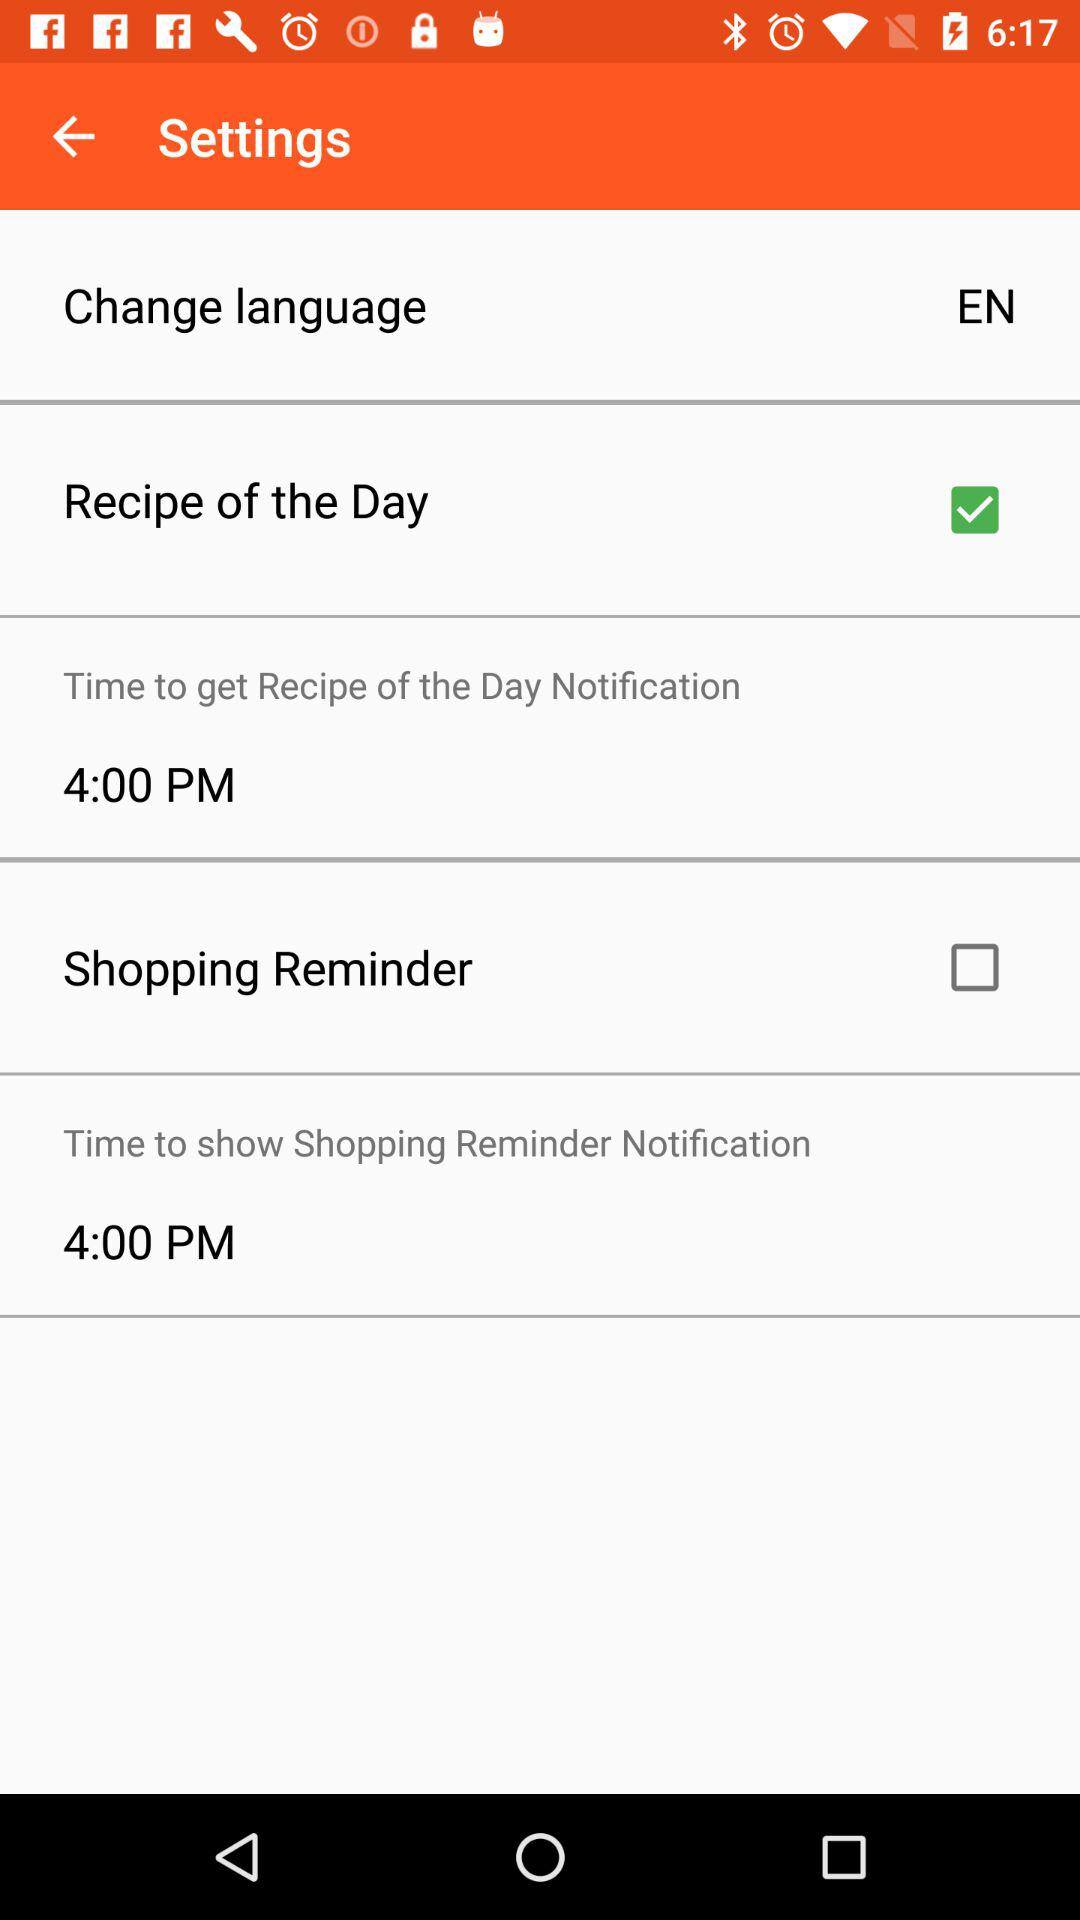What is the time to show a shopping reminder? The time is 4:00 PM. 